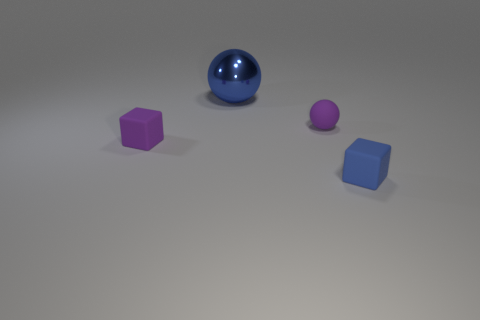Subtract all blue spheres. How many spheres are left? 1 Subtract 2 balls. How many balls are left? 0 Add 2 blue matte things. How many objects exist? 6 Subtract 0 brown balls. How many objects are left? 4 Subtract all purple spheres. Subtract all purple cylinders. How many spheres are left? 1 Subtract all blue cylinders. How many blue spheres are left? 1 Subtract all big blue objects. Subtract all tiny blue matte objects. How many objects are left? 2 Add 1 shiny spheres. How many shiny spheres are left? 2 Add 2 blue cubes. How many blue cubes exist? 3 